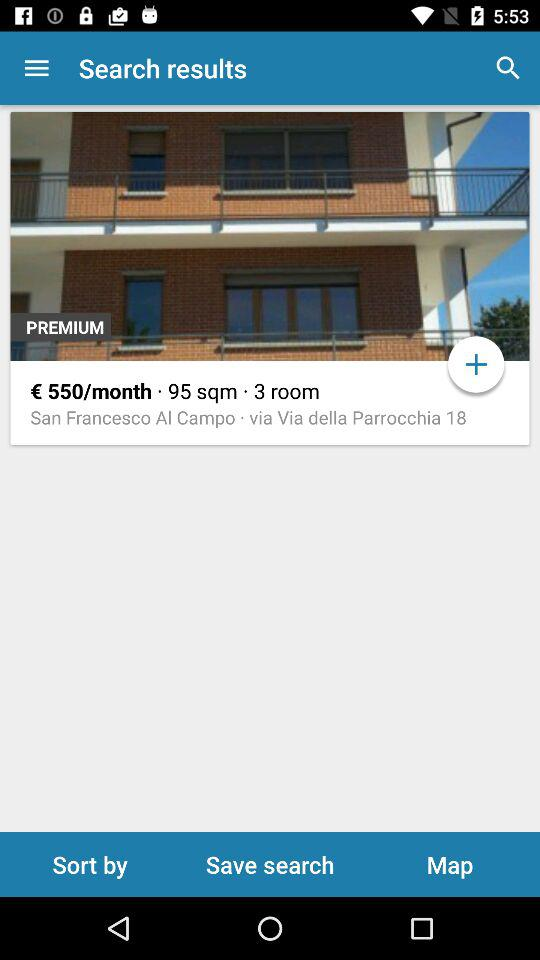What is the mentioned location? The mentioned location is San Francesco Al Campo. 